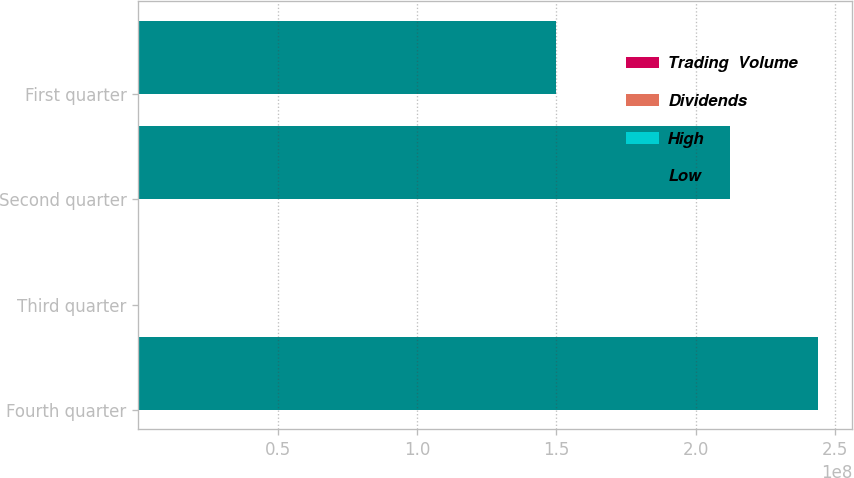<chart> <loc_0><loc_0><loc_500><loc_500><stacked_bar_chart><ecel><fcel>Fourth quarter<fcel>Third quarter<fcel>Second quarter<fcel>First quarter<nl><fcel>Trading  Volume<fcel>35<fcel>38.9<fcel>34.94<fcel>31.61<nl><fcel>Dividends<fcel>21.13<fcel>24.25<fcel>25.3<fcel>19.92<nl><fcel>High<fcel>0.6<fcel>0.59<fcel>0.07<fcel>0.07<nl><fcel>Low<fcel>2.43985e+08<fcel>25.3<fcel>2.12392e+08<fcel>1.49826e+08<nl></chart> 